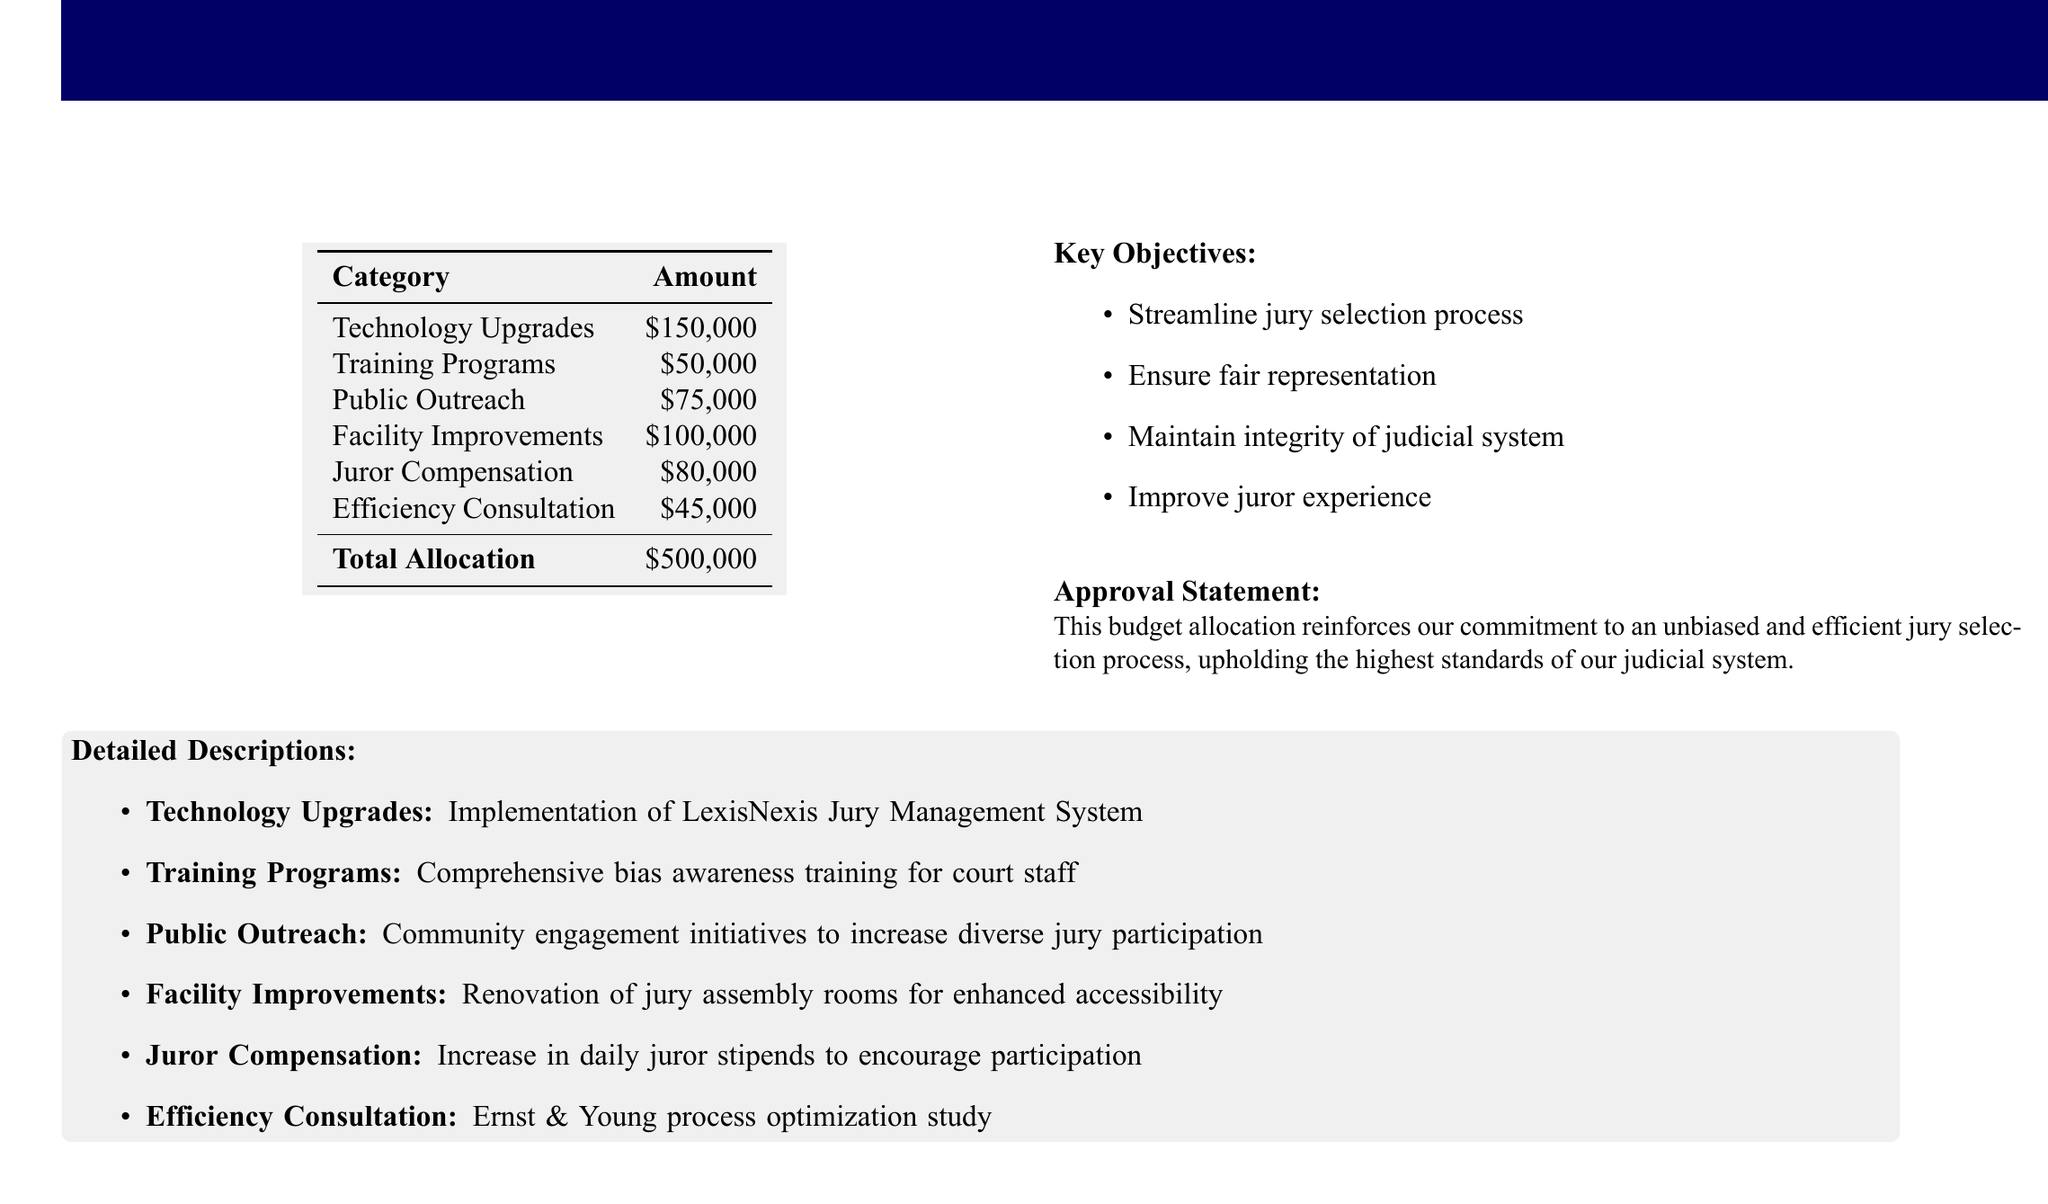what is the total allocation for the jury selection process improvements? The total allocation is the sum of all categories listed, which amounts to $500,000.
Answer: $500,000 how much is allocated for technology upgrades? The technology upgrades category specifically lists an allocation of $150,000.
Answer: $150,000 what is the amount set for juror compensation? The juror compensation category indicates a specific allocation of $80,000.
Answer: $80,000 what is one of the key objectives stated in the document? The key objectives outline goals such as streamlining the jury selection process, ensuring fair representation, and maintaining integrity.
Answer: Streamline jury selection process who conducted the efficiency consultation? The detailed description mentions that Ernst & Young conducted the efficiency consultation.
Answer: Ernst & Young how much is allocated for training programs? The training programs category indicates a budget allocation of $50,000.
Answer: $50,000 what type of training is included under the training programs category? The document states that the training programs include comprehensive bias awareness training for court staff.
Answer: bias awareness training what is one purpose of public outreach spending? The public outreach spending aims to increase diverse jury participation as part of community engagement initiatives.
Answer: increase diverse jury participation 